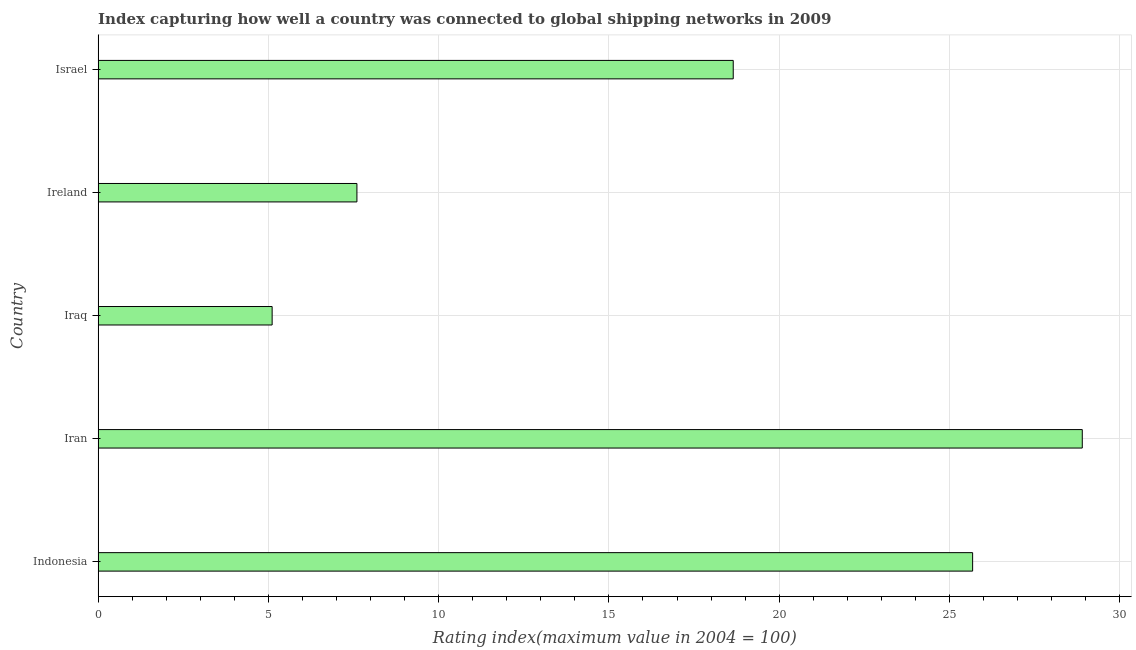What is the title of the graph?
Your answer should be compact. Index capturing how well a country was connected to global shipping networks in 2009. What is the label or title of the X-axis?
Offer a very short reply. Rating index(maximum value in 2004 = 100). What is the liner shipping connectivity index in Ireland?
Give a very brief answer. 7.6. Across all countries, what is the maximum liner shipping connectivity index?
Your response must be concise. 28.9. Across all countries, what is the minimum liner shipping connectivity index?
Your answer should be compact. 5.11. In which country was the liner shipping connectivity index maximum?
Your answer should be very brief. Iran. In which country was the liner shipping connectivity index minimum?
Your answer should be compact. Iraq. What is the sum of the liner shipping connectivity index?
Offer a terse response. 85.94. What is the difference between the liner shipping connectivity index in Iran and Iraq?
Make the answer very short. 23.79. What is the average liner shipping connectivity index per country?
Provide a succinct answer. 17.19. What is the median liner shipping connectivity index?
Your answer should be very brief. 18.65. In how many countries, is the liner shipping connectivity index greater than 4 ?
Ensure brevity in your answer.  5. What is the ratio of the liner shipping connectivity index in Iraq to that in Ireland?
Give a very brief answer. 0.67. Is the liner shipping connectivity index in Iran less than that in Iraq?
Provide a short and direct response. No. Is the difference between the liner shipping connectivity index in Iraq and Israel greater than the difference between any two countries?
Provide a short and direct response. No. What is the difference between the highest and the second highest liner shipping connectivity index?
Make the answer very short. 3.22. Is the sum of the liner shipping connectivity index in Iran and Israel greater than the maximum liner shipping connectivity index across all countries?
Provide a short and direct response. Yes. What is the difference between the highest and the lowest liner shipping connectivity index?
Offer a very short reply. 23.79. In how many countries, is the liner shipping connectivity index greater than the average liner shipping connectivity index taken over all countries?
Your answer should be compact. 3. Are the values on the major ticks of X-axis written in scientific E-notation?
Make the answer very short. No. What is the Rating index(maximum value in 2004 = 100) of Indonesia?
Provide a succinct answer. 25.68. What is the Rating index(maximum value in 2004 = 100) of Iran?
Your answer should be very brief. 28.9. What is the Rating index(maximum value in 2004 = 100) in Iraq?
Provide a succinct answer. 5.11. What is the Rating index(maximum value in 2004 = 100) in Israel?
Your answer should be very brief. 18.65. What is the difference between the Rating index(maximum value in 2004 = 100) in Indonesia and Iran?
Ensure brevity in your answer.  -3.22. What is the difference between the Rating index(maximum value in 2004 = 100) in Indonesia and Iraq?
Give a very brief answer. 20.57. What is the difference between the Rating index(maximum value in 2004 = 100) in Indonesia and Ireland?
Give a very brief answer. 18.08. What is the difference between the Rating index(maximum value in 2004 = 100) in Indonesia and Israel?
Offer a terse response. 7.03. What is the difference between the Rating index(maximum value in 2004 = 100) in Iran and Iraq?
Give a very brief answer. 23.79. What is the difference between the Rating index(maximum value in 2004 = 100) in Iran and Ireland?
Provide a succinct answer. 21.3. What is the difference between the Rating index(maximum value in 2004 = 100) in Iran and Israel?
Give a very brief answer. 10.25. What is the difference between the Rating index(maximum value in 2004 = 100) in Iraq and Ireland?
Provide a short and direct response. -2.49. What is the difference between the Rating index(maximum value in 2004 = 100) in Iraq and Israel?
Provide a succinct answer. -13.54. What is the difference between the Rating index(maximum value in 2004 = 100) in Ireland and Israel?
Give a very brief answer. -11.05. What is the ratio of the Rating index(maximum value in 2004 = 100) in Indonesia to that in Iran?
Provide a succinct answer. 0.89. What is the ratio of the Rating index(maximum value in 2004 = 100) in Indonesia to that in Iraq?
Provide a succinct answer. 5.03. What is the ratio of the Rating index(maximum value in 2004 = 100) in Indonesia to that in Ireland?
Make the answer very short. 3.38. What is the ratio of the Rating index(maximum value in 2004 = 100) in Indonesia to that in Israel?
Ensure brevity in your answer.  1.38. What is the ratio of the Rating index(maximum value in 2004 = 100) in Iran to that in Iraq?
Your response must be concise. 5.66. What is the ratio of the Rating index(maximum value in 2004 = 100) in Iran to that in Ireland?
Your response must be concise. 3.8. What is the ratio of the Rating index(maximum value in 2004 = 100) in Iran to that in Israel?
Provide a succinct answer. 1.55. What is the ratio of the Rating index(maximum value in 2004 = 100) in Iraq to that in Ireland?
Give a very brief answer. 0.67. What is the ratio of the Rating index(maximum value in 2004 = 100) in Iraq to that in Israel?
Ensure brevity in your answer.  0.27. What is the ratio of the Rating index(maximum value in 2004 = 100) in Ireland to that in Israel?
Your answer should be very brief. 0.41. 